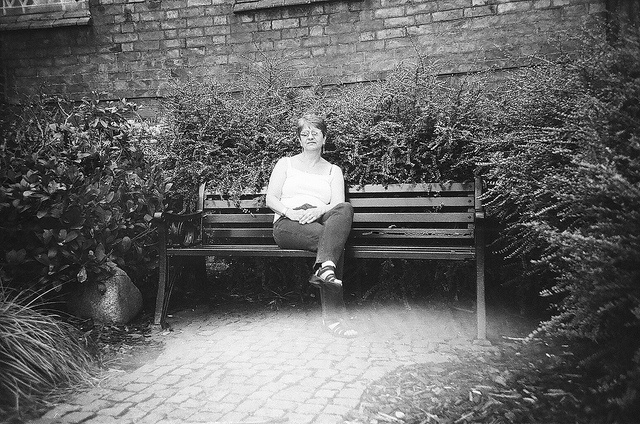Describe the objects in this image and their specific colors. I can see bench in black, gray, darkgray, and lightgray tones and people in black, white, gray, and darkgray tones in this image. 